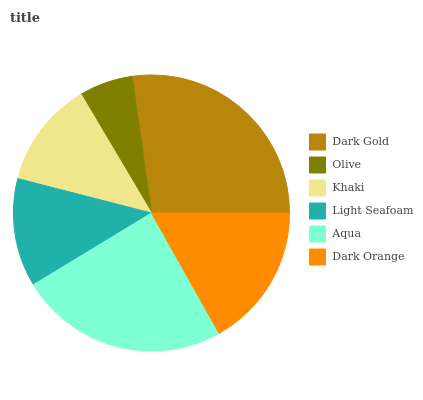Is Olive the minimum?
Answer yes or no. Yes. Is Dark Gold the maximum?
Answer yes or no. Yes. Is Khaki the minimum?
Answer yes or no. No. Is Khaki the maximum?
Answer yes or no. No. Is Khaki greater than Olive?
Answer yes or no. Yes. Is Olive less than Khaki?
Answer yes or no. Yes. Is Olive greater than Khaki?
Answer yes or no. No. Is Khaki less than Olive?
Answer yes or no. No. Is Dark Orange the high median?
Answer yes or no. Yes. Is Light Seafoam the low median?
Answer yes or no. Yes. Is Aqua the high median?
Answer yes or no. No. Is Dark Orange the low median?
Answer yes or no. No. 